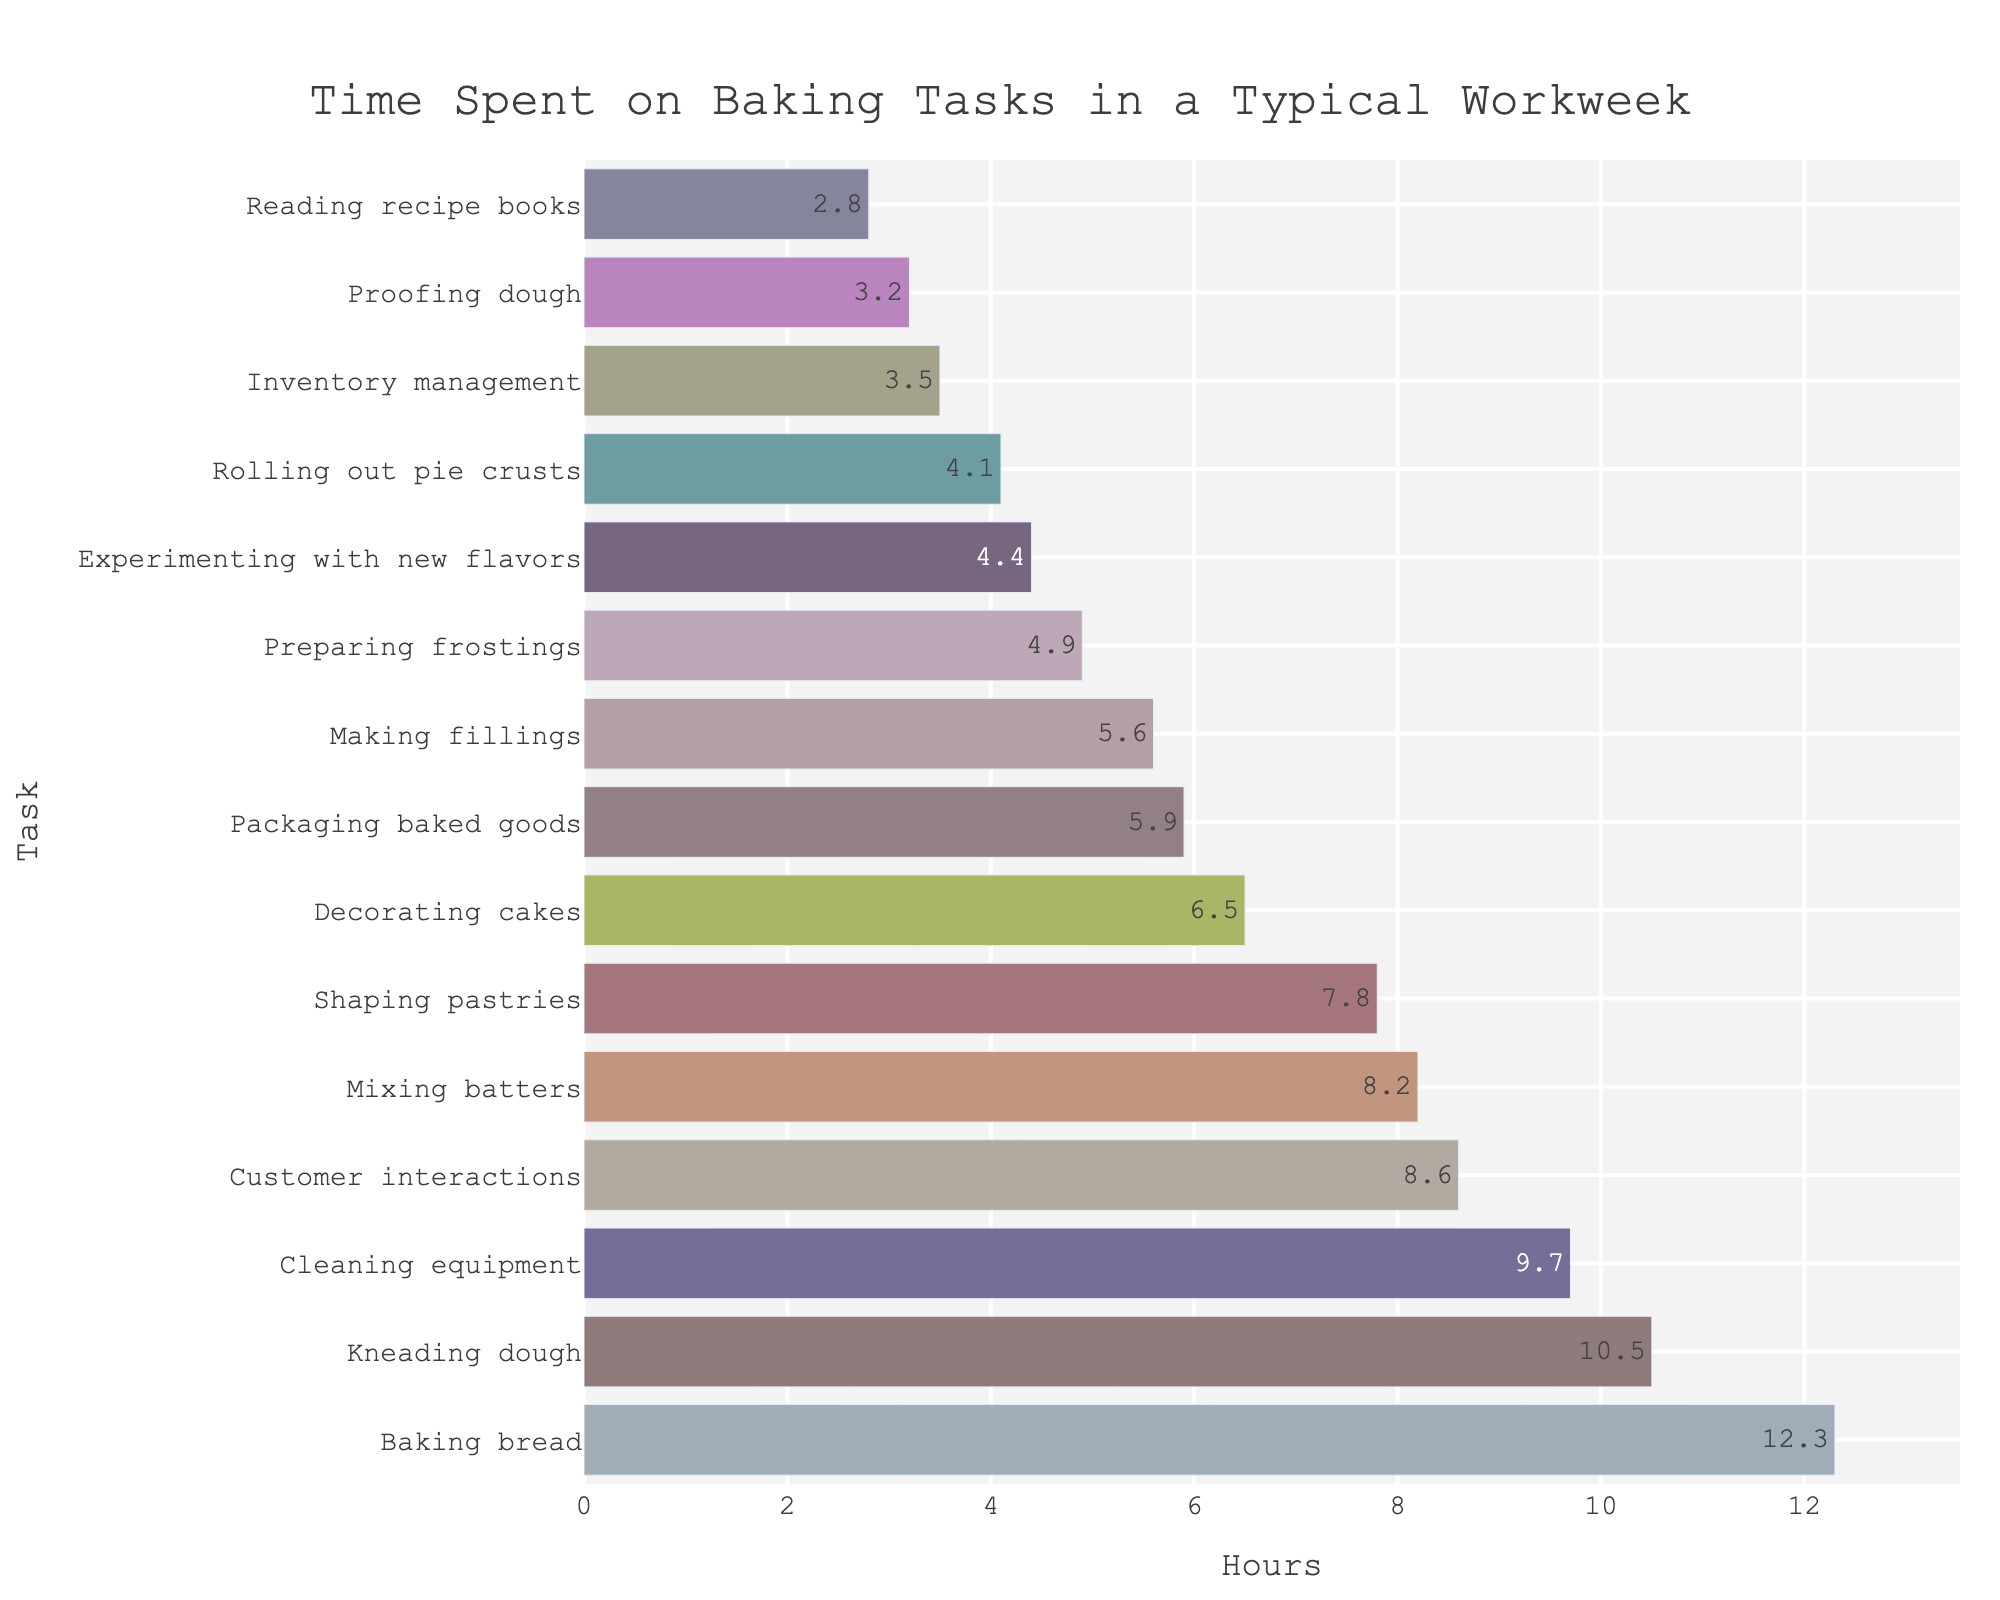Which task takes the most amount of time? The figure shows a bar chart ordered by the time spent on each baking task. The longest bar corresponds to the task with the highest number of hours. This task is "Baking bread" with 12.3 hours.
Answer: Baking bread How much time is spent on kneading dough compared to mixing batters? By looking at the length of the bars for "Kneading dough" and "Mixing batters," we see that "Kneading dough" takes 10.5 hours and "Mixing batters" takes 8.2 hours.
Answer: Kneading dough: 10.5 hours, Mixing batters: 8.2 hours What's the combined time spent on decorating cakes and shaping pastries? To find the total time, sum the hours spent on both tasks: 6.5 hours for "Decorating cakes" and 7.8 hours for "Shaping pastries." Therefore, 6.5 + 7.8 = 14.3 hours.
Answer: 14.3 hours Which task takes more time: making fillings or preparing frostings? By referring to the bar lengths for "Making fillings" and "Preparing frostings," we see that making fillings takes 5.6 hours and preparing frostings takes 4.9 hours. Thus, making fillings takes more time.
Answer: Making fillings How many tasks take more than 7 hours? Count the number of bars representing tasks that exceed 7 hours. These are: "Baking bread," "Kneading dough," "Mixing batters," "Shaping pastries," "Cleaning equipment," and "Customer interactions." This totals to 6 tasks.
Answer: 6 tasks What is the difference in time spent between the shortest and longest tasks? The shortest task is "Reading recipe books" at 2.8 hours, and the longest is "Baking bread" at 12.3 hours. The difference is 12.3 - 2.8 = 9.5 hours.
Answer: 9.5 hours Is the time spent experimenting with new flavors closer to the time spent rolling out pie crusts or proofing dough? The task "Experimenting with new flavors" takes 4.4 hours, "Rolling out pie crusts" takes 4.1 hours, and "Proofing dough" takes 3.2 hours. The difference between experimenting with new flavors and rolling out pie crusts is 0.3 hours, while the difference with proofing dough is 1.2 hours. Therefore, it's closer to rolling out pie crusts.
Answer: Rolling out pie crusts What is the average time spent on customer interactions, cleaning equipment, and inventory management? To find the average, sum the hours spent on all three tasks and divide by 3. "Customer interactions" takes 8.6 hours, "Cleaning equipment" takes 9.7 hours, and "Inventory management" takes 3.5 hours. The sum is 8.6 + 9.7 + 3.5 = 21.8, so the average is 21.8 / 3 = 7.3 hours.
Answer: 7.3 hours What's the median time spent on all tasks listed? To find the median, order all values and find the middle one. The ordered hours are: 2.8, 3.2, 3.5, 4.1, 4.4, 4.9, 5.6, 5.9, 6.5, 7.8, 8.2, 8.6, 9.7, 10.5, 12.3. There are 15 tasks, so the median is the 8th value, which is 5.9 hours.
Answer: 5.9 hours 